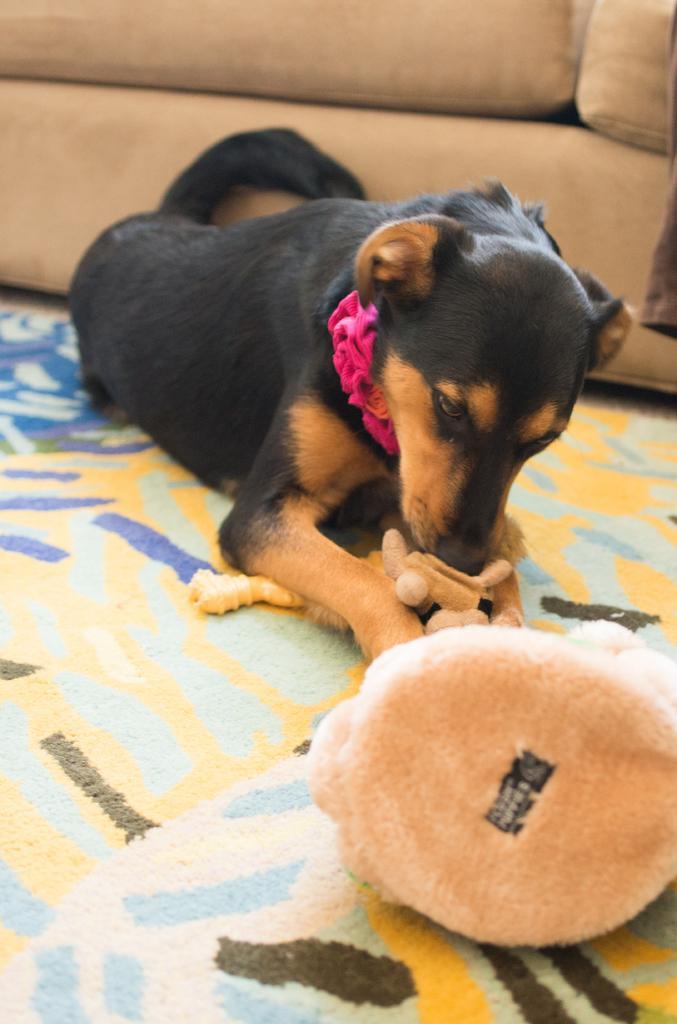In one or two sentences, can you explain what this image depicts? As we can see in the image there is toy, mat, black color dog and sofa. 